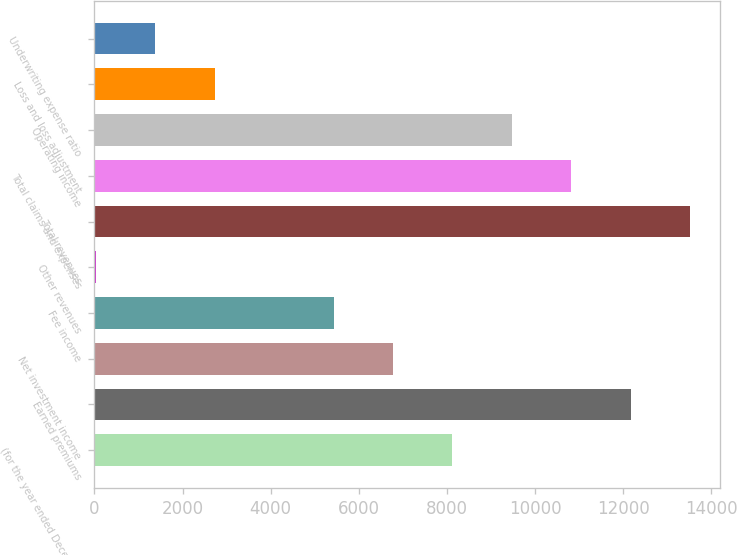<chart> <loc_0><loc_0><loc_500><loc_500><bar_chart><fcel>(for the year ended December<fcel>Earned premiums<fcel>Net investment income<fcel>Fee income<fcel>Other revenues<fcel>Total revenues<fcel>Total claims and expenses<fcel>Operating income<fcel>Loss and loss adjustment<fcel>Underwriting expense ratio<nl><fcel>8122.2<fcel>12168.3<fcel>6773.5<fcel>5424.8<fcel>30<fcel>13517<fcel>10819.6<fcel>9470.9<fcel>2727.4<fcel>1378.7<nl></chart> 